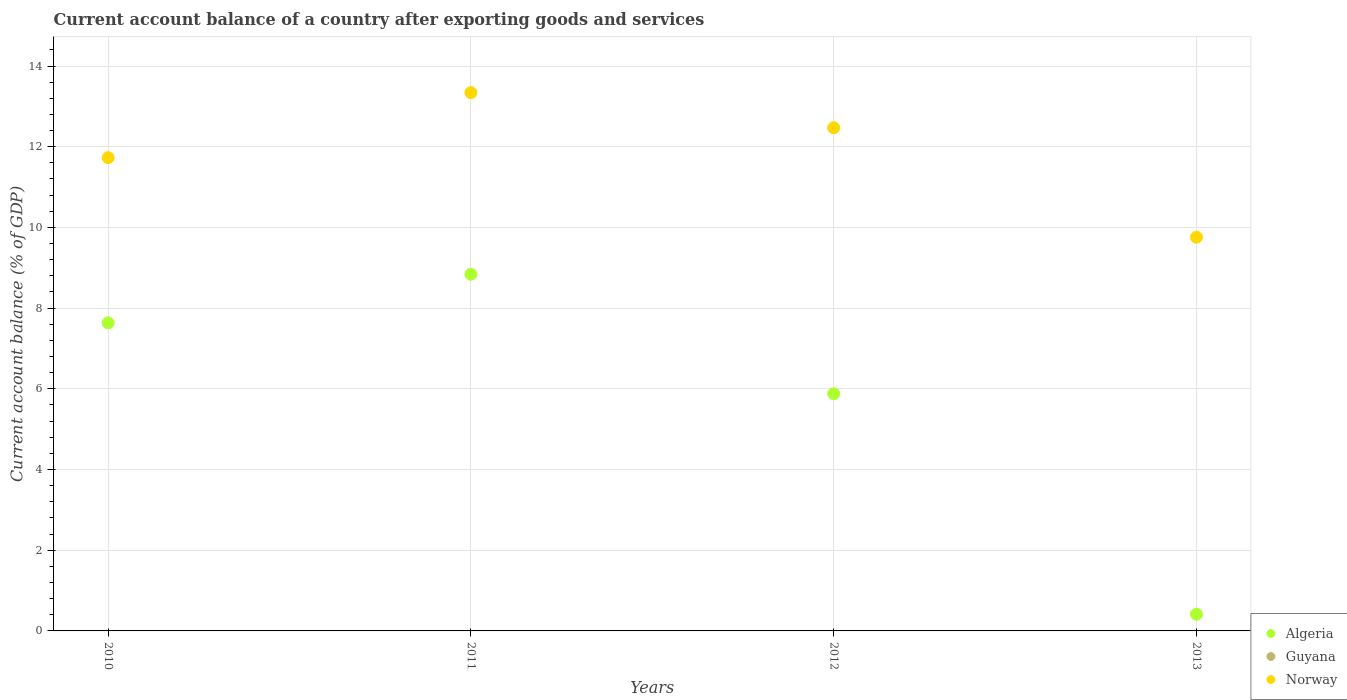What is the account balance in Norway in 2011?
Your answer should be very brief. 13.34. Across all years, what is the maximum account balance in Norway?
Keep it short and to the point. 13.34. Across all years, what is the minimum account balance in Guyana?
Offer a terse response. 0. What is the difference between the account balance in Norway in 2011 and that in 2013?
Your answer should be very brief. 3.58. What is the difference between the account balance in Guyana in 2011 and the account balance in Norway in 2012?
Ensure brevity in your answer.  -12.47. What is the average account balance in Norway per year?
Offer a terse response. 11.82. In the year 2011, what is the difference between the account balance in Algeria and account balance in Norway?
Your answer should be compact. -4.5. What is the ratio of the account balance in Algeria in 2011 to that in 2013?
Your response must be concise. 21.33. Is the account balance in Algeria in 2010 less than that in 2011?
Ensure brevity in your answer.  Yes. Is the difference between the account balance in Algeria in 2011 and 2013 greater than the difference between the account balance in Norway in 2011 and 2013?
Offer a terse response. Yes. What is the difference between the highest and the second highest account balance in Norway?
Provide a short and direct response. 0.87. What is the difference between the highest and the lowest account balance in Algeria?
Provide a short and direct response. 8.43. Is the sum of the account balance in Norway in 2011 and 2012 greater than the maximum account balance in Algeria across all years?
Ensure brevity in your answer.  Yes. Is it the case that in every year, the sum of the account balance in Norway and account balance in Algeria  is greater than the account balance in Guyana?
Your answer should be very brief. Yes. Is the account balance in Guyana strictly greater than the account balance in Norway over the years?
Provide a short and direct response. No. How many dotlines are there?
Ensure brevity in your answer.  2. What is the difference between two consecutive major ticks on the Y-axis?
Offer a very short reply. 2. Are the values on the major ticks of Y-axis written in scientific E-notation?
Provide a short and direct response. No. Does the graph contain grids?
Offer a very short reply. Yes. What is the title of the graph?
Ensure brevity in your answer.  Current account balance of a country after exporting goods and services. Does "Zimbabwe" appear as one of the legend labels in the graph?
Provide a succinct answer. No. What is the label or title of the X-axis?
Make the answer very short. Years. What is the label or title of the Y-axis?
Offer a very short reply. Current account balance (% of GDP). What is the Current account balance (% of GDP) in Algeria in 2010?
Ensure brevity in your answer.  7.64. What is the Current account balance (% of GDP) of Norway in 2010?
Make the answer very short. 11.73. What is the Current account balance (% of GDP) in Algeria in 2011?
Make the answer very short. 8.84. What is the Current account balance (% of GDP) in Guyana in 2011?
Ensure brevity in your answer.  0. What is the Current account balance (% of GDP) of Norway in 2011?
Your answer should be very brief. 13.34. What is the Current account balance (% of GDP) in Algeria in 2012?
Keep it short and to the point. 5.88. What is the Current account balance (% of GDP) in Guyana in 2012?
Your answer should be compact. 0. What is the Current account balance (% of GDP) of Norway in 2012?
Your answer should be very brief. 12.47. What is the Current account balance (% of GDP) in Algeria in 2013?
Make the answer very short. 0.41. What is the Current account balance (% of GDP) of Guyana in 2013?
Give a very brief answer. 0. What is the Current account balance (% of GDP) in Norway in 2013?
Provide a succinct answer. 9.76. Across all years, what is the maximum Current account balance (% of GDP) of Algeria?
Keep it short and to the point. 8.84. Across all years, what is the maximum Current account balance (% of GDP) in Norway?
Keep it short and to the point. 13.34. Across all years, what is the minimum Current account balance (% of GDP) of Algeria?
Offer a terse response. 0.41. Across all years, what is the minimum Current account balance (% of GDP) in Norway?
Offer a very short reply. 9.76. What is the total Current account balance (% of GDP) in Algeria in the graph?
Provide a succinct answer. 22.77. What is the total Current account balance (% of GDP) of Norway in the graph?
Provide a short and direct response. 47.29. What is the difference between the Current account balance (% of GDP) of Algeria in 2010 and that in 2011?
Offer a terse response. -1.2. What is the difference between the Current account balance (% of GDP) in Norway in 2010 and that in 2011?
Provide a succinct answer. -1.61. What is the difference between the Current account balance (% of GDP) of Algeria in 2010 and that in 2012?
Give a very brief answer. 1.76. What is the difference between the Current account balance (% of GDP) of Norway in 2010 and that in 2012?
Keep it short and to the point. -0.74. What is the difference between the Current account balance (% of GDP) of Algeria in 2010 and that in 2013?
Your response must be concise. 7.22. What is the difference between the Current account balance (% of GDP) in Norway in 2010 and that in 2013?
Offer a very short reply. 1.97. What is the difference between the Current account balance (% of GDP) of Algeria in 2011 and that in 2012?
Your answer should be compact. 2.96. What is the difference between the Current account balance (% of GDP) of Norway in 2011 and that in 2012?
Ensure brevity in your answer.  0.87. What is the difference between the Current account balance (% of GDP) of Algeria in 2011 and that in 2013?
Keep it short and to the point. 8.43. What is the difference between the Current account balance (% of GDP) of Norway in 2011 and that in 2013?
Offer a terse response. 3.58. What is the difference between the Current account balance (% of GDP) in Algeria in 2012 and that in 2013?
Your answer should be very brief. 5.46. What is the difference between the Current account balance (% of GDP) of Norway in 2012 and that in 2013?
Your response must be concise. 2.71. What is the difference between the Current account balance (% of GDP) of Algeria in 2010 and the Current account balance (% of GDP) of Norway in 2011?
Give a very brief answer. -5.7. What is the difference between the Current account balance (% of GDP) of Algeria in 2010 and the Current account balance (% of GDP) of Norway in 2012?
Keep it short and to the point. -4.83. What is the difference between the Current account balance (% of GDP) of Algeria in 2010 and the Current account balance (% of GDP) of Norway in 2013?
Provide a short and direct response. -2.12. What is the difference between the Current account balance (% of GDP) in Algeria in 2011 and the Current account balance (% of GDP) in Norway in 2012?
Offer a very short reply. -3.63. What is the difference between the Current account balance (% of GDP) of Algeria in 2011 and the Current account balance (% of GDP) of Norway in 2013?
Your answer should be compact. -0.92. What is the difference between the Current account balance (% of GDP) in Algeria in 2012 and the Current account balance (% of GDP) in Norway in 2013?
Make the answer very short. -3.88. What is the average Current account balance (% of GDP) of Algeria per year?
Offer a very short reply. 5.69. What is the average Current account balance (% of GDP) in Norway per year?
Provide a short and direct response. 11.82. In the year 2010, what is the difference between the Current account balance (% of GDP) in Algeria and Current account balance (% of GDP) in Norway?
Offer a very short reply. -4.09. In the year 2011, what is the difference between the Current account balance (% of GDP) of Algeria and Current account balance (% of GDP) of Norway?
Your answer should be very brief. -4.5. In the year 2012, what is the difference between the Current account balance (% of GDP) of Algeria and Current account balance (% of GDP) of Norway?
Your response must be concise. -6.59. In the year 2013, what is the difference between the Current account balance (% of GDP) in Algeria and Current account balance (% of GDP) in Norway?
Offer a terse response. -9.34. What is the ratio of the Current account balance (% of GDP) of Algeria in 2010 to that in 2011?
Offer a very short reply. 0.86. What is the ratio of the Current account balance (% of GDP) in Norway in 2010 to that in 2011?
Make the answer very short. 0.88. What is the ratio of the Current account balance (% of GDP) in Algeria in 2010 to that in 2012?
Your answer should be very brief. 1.3. What is the ratio of the Current account balance (% of GDP) of Norway in 2010 to that in 2012?
Keep it short and to the point. 0.94. What is the ratio of the Current account balance (% of GDP) in Algeria in 2010 to that in 2013?
Make the answer very short. 18.42. What is the ratio of the Current account balance (% of GDP) of Norway in 2010 to that in 2013?
Offer a very short reply. 1.2. What is the ratio of the Current account balance (% of GDP) of Algeria in 2011 to that in 2012?
Your answer should be very brief. 1.5. What is the ratio of the Current account balance (% of GDP) of Norway in 2011 to that in 2012?
Give a very brief answer. 1.07. What is the ratio of the Current account balance (% of GDP) in Algeria in 2011 to that in 2013?
Your answer should be compact. 21.33. What is the ratio of the Current account balance (% of GDP) of Norway in 2011 to that in 2013?
Provide a short and direct response. 1.37. What is the ratio of the Current account balance (% of GDP) of Algeria in 2012 to that in 2013?
Provide a succinct answer. 14.18. What is the ratio of the Current account balance (% of GDP) of Norway in 2012 to that in 2013?
Make the answer very short. 1.28. What is the difference between the highest and the second highest Current account balance (% of GDP) of Algeria?
Offer a very short reply. 1.2. What is the difference between the highest and the second highest Current account balance (% of GDP) in Norway?
Provide a succinct answer. 0.87. What is the difference between the highest and the lowest Current account balance (% of GDP) in Algeria?
Provide a succinct answer. 8.43. What is the difference between the highest and the lowest Current account balance (% of GDP) of Norway?
Provide a short and direct response. 3.58. 